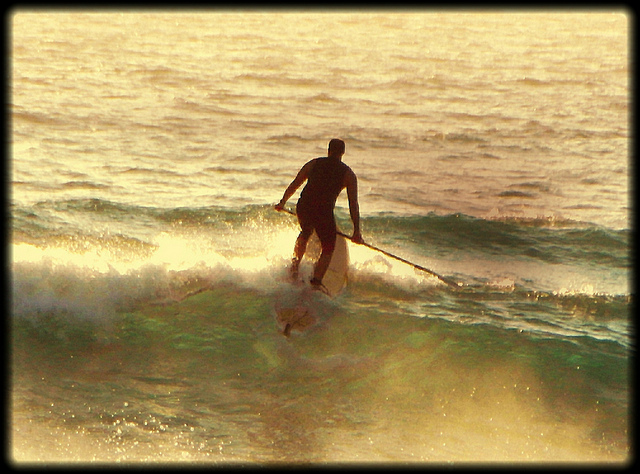If you imagine the man is in an alternate universe, what could be different about his paddleboarding experience? In an alternate universe, the man might find himself paddleboarding not on water, but on a liquid-like surface made of light or energy. The waves could be luminous, changing colors with every motion, and instead of using a traditional paddle, he might navigate with a device that bends and shapes the energy waves. In this fantastical scenario, he could encounter otherworldly creatures, like flying jellyfish or glowing fish that illuminate his path. The ambient sounds would be a symphony of celestial tones, adding a surreal auditory experience to this otherworldly paddleboarding adventure. 